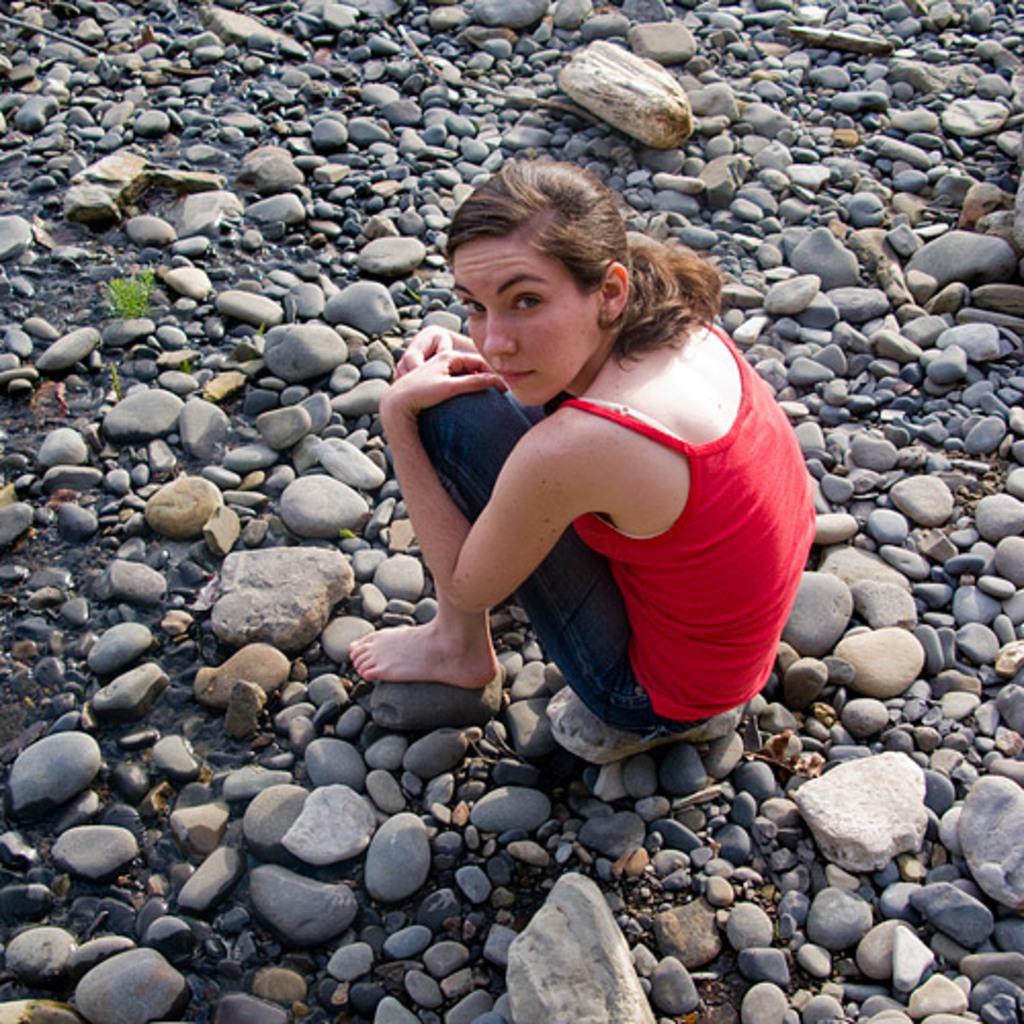Describe this image in one or two sentences. In this image I can see many stones on the ground. In the middle of the image there is a woman sitting on the ground and looking at the picture. 